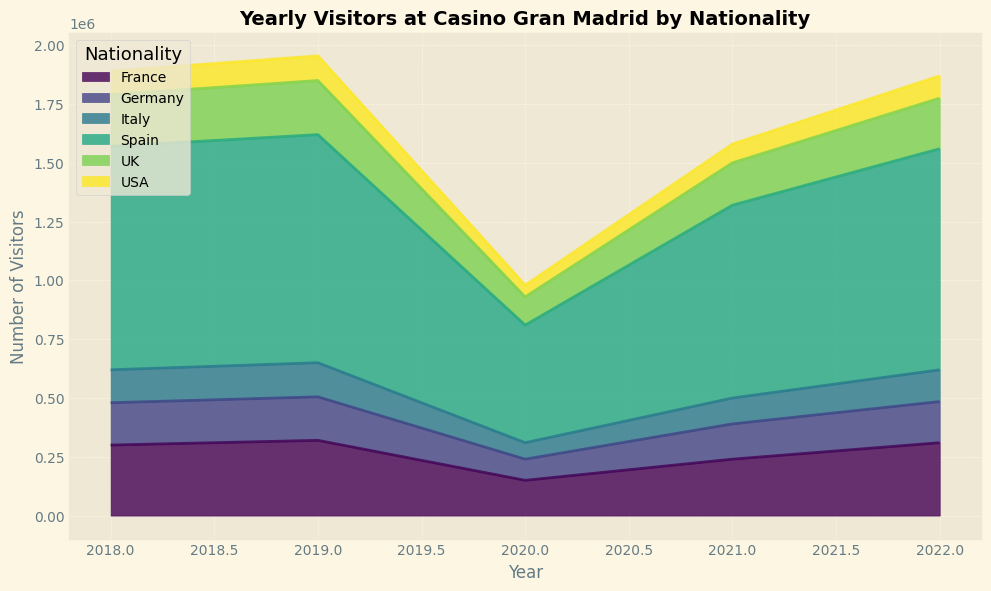What's the nationality with the highest number of visitors in 2022? Looking at the segmented areas in the chart for 2022, the largest area belongs to Spain, indicating it has the highest number of visitors in that year.
Answer: Spain How did the number of visitors from the USA change from 2019 to 2020? In 2019, the number of visitors from the USA is higher. Observation shows a reduced area for the USA in 2020, thus the number of visitors decreased.
Answer: Decreased Which year experienced the lowest number of total visitors, and how can you tell? The year with the smallest combined area for all nationalities visually indicates the lowest total visitors, which is 2020.
Answer: 2020 How did the visitor statistics from Italy evolve from 2018 to 2022? By observing the changing area size for Italy in each year: 2018 starts high, drops significantly in 2020, and then gradually increases again through 2022.
Answer: Decreased until 2020, then increased Compare the number of visitors from Germany and France in 2021. Which nationality had more visitors? By comparing the areas for Germany and France in 2021, it's evident that France has a larger area, thus more visitors.
Answer: France Calculate the total number of visitors in 2018 by summing the visitors from all nationalities. Sum the visitors from each nationality known from the data provided for 2018: 950000 (Spain) + 300000 (France) + 220000 (UK) + 180000 (Germany) + 140000 (Italy) + 100000 (USA) = 1890000.
Answer: 1890000 Did the number of visitors from Spain ever drop below 800,000? If so, when? Observing the area for Spain, it significantly drops below 800,000 in 2020.
Answer: Yes, in 2020 What's the average number of visitors from the UK across all years provided? Sum the visitors from the UK from each year: 220000 (2018) + 230000 (2019) + 120000 (2020) + 180000 (2021) + 215000 (2022) = 965000. There are 5 years, so average is 965000 / 5 = 193000.
Answer: 193000 How does the trend for visitors from Spain contrast with that of visitors from the USA from 2018 to 2022? Spain shows an overall similar pattern with fluctuations, a significant dip in 2020, and gradual recovery. The USA also dips in 2020 but does not recover as significantly.
Answer: Spain recovers better than USA What is the difference in the number of visitors from France between 2019 and 2021? Visitors from France in 2019 are larger. The number in those years is 320000 (2019) and 240000 (2021), difference is 320000 - 240000 = 80000.
Answer: 80000 